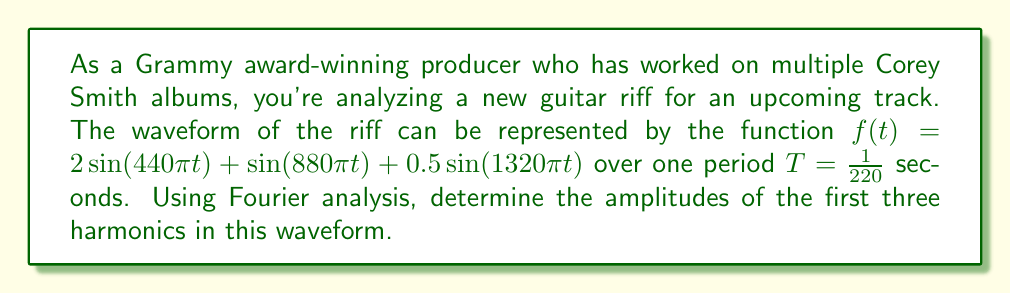What is the answer to this math problem? To determine the harmonic content of this musical waveform using Fourier analysis, we need to calculate the Fourier coefficients. For a periodic function $f(t)$ with period $T$, the Fourier series is given by:

$$f(t) = a_0 + \sum_{n=1}^{\infty} (a_n \cos(n\omega_0 t) + b_n \sin(n\omega_0 t))$$

where $\omega_0 = \frac{2\pi}{T}$ is the fundamental frequency.

The amplitudes of the harmonics are given by $c_n = \sqrt{a_n^2 + b_n^2}$.

For this problem:
1. $T = \frac{1}{220}$ seconds
2. $\omega_0 = 2\pi \cdot 220 = 440\pi$ rad/s

Given the waveform:
$$f(t) = 2\sin(440\pi t) + \sin(880\pi t) + 0.5\sin(1320\pi t)$$

We can identify the harmonics:
- First harmonic (fundamental): $2\sin(440\pi t)$
- Second harmonic: $\sin(880\pi t)$
- Third harmonic: $0.5\sin(1320\pi t)$

The amplitudes are directly visible:
1. First harmonic: $c_1 = 2$
2. Second harmonic: $c_2 = 1$
3. Third harmonic: $c_3 = 0.5$

Note that in this case, all cosine terms are zero, and the sine terms directly give us the amplitudes.
Answer: The amplitudes of the first three harmonics are:
1. First harmonic: $c_1 = 2$
2. Second harmonic: $c_2 = 1$
3. Third harmonic: $c_3 = 0.5$ 